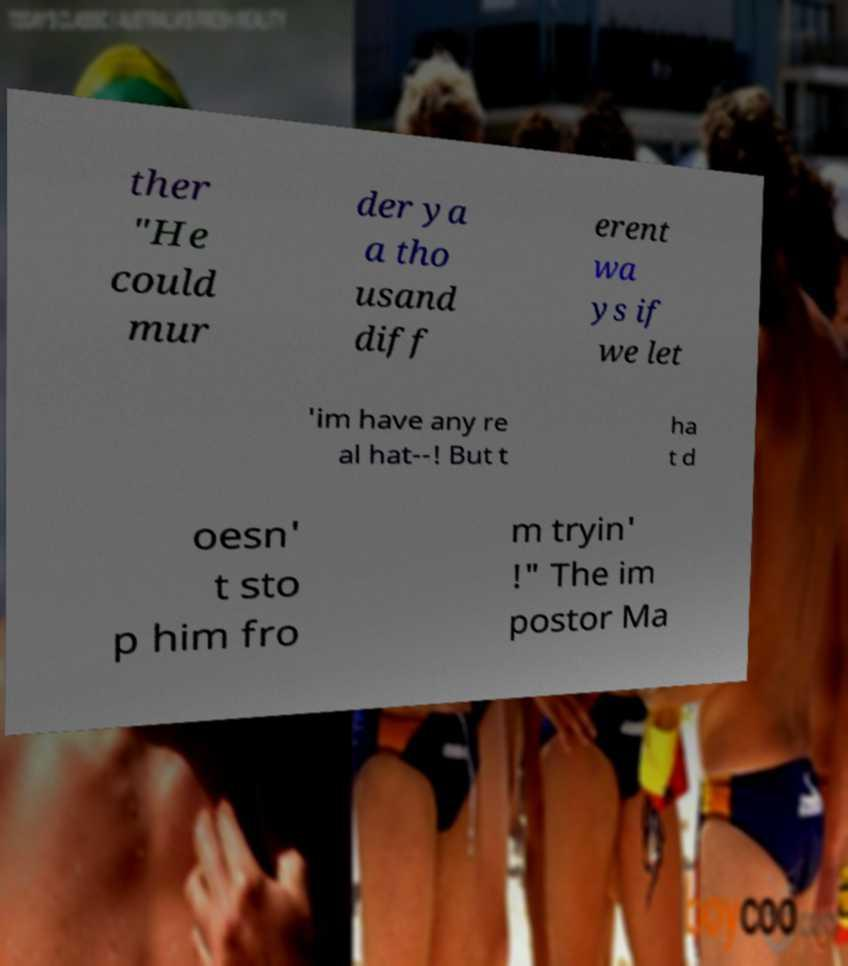I need the written content from this picture converted into text. Can you do that? ther "He could mur der ya a tho usand diff erent wa ys if we let 'im have any re al hat--! But t ha t d oesn' t sto p him fro m tryin' !" The im postor Ma 